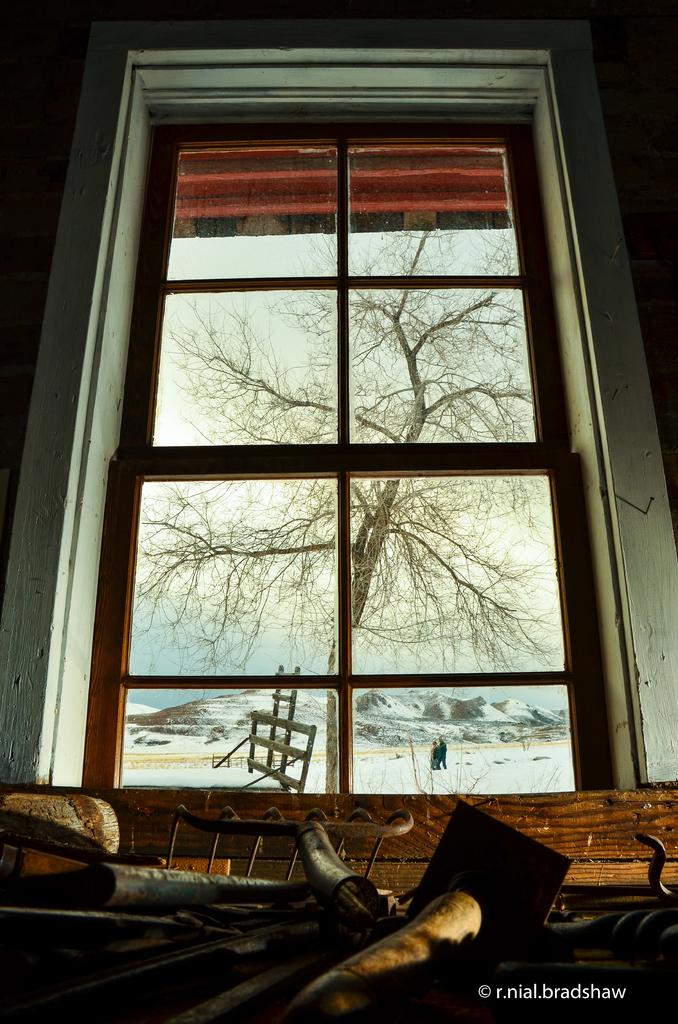What can be seen through the window in the image? Trees, persons, the hill, and the sky are visible through the window in the image. What is located in front of the window? There are metal items and text in front of the window. What type of pancake is being served on the table in the image? There is no table or pancake present in the image; it only features a window with various elements visible through it. 